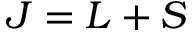<formula> <loc_0><loc_0><loc_500><loc_500>J = L + S</formula> 